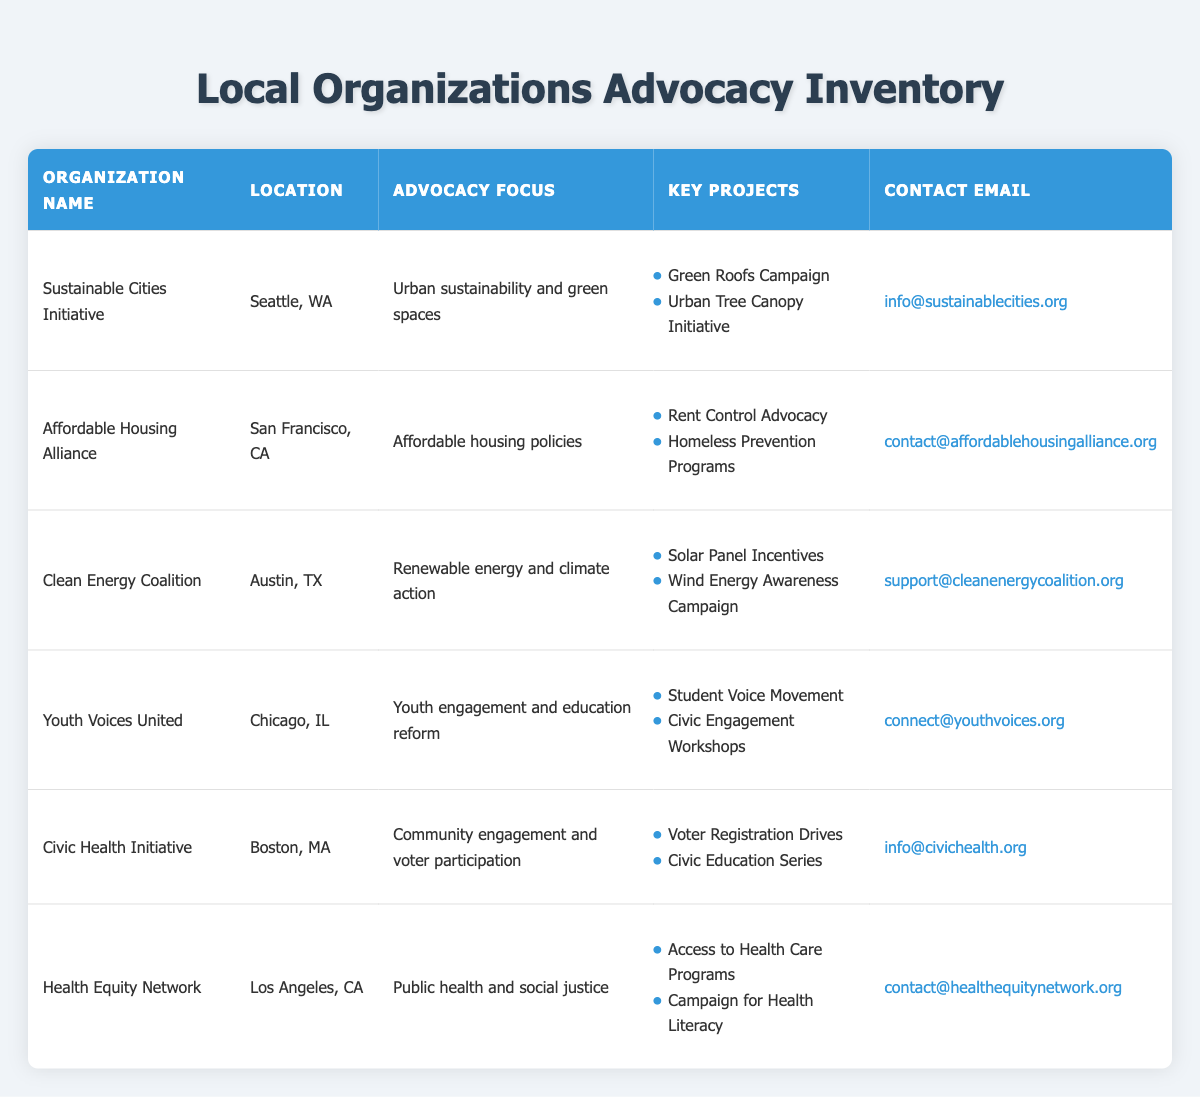What is the advocacy focus of the Clean Energy Coalition? The table shows that the advocacy focus of the Clean Energy Coalition, located in Austin, TX, is renewable energy and climate action.
Answer: Renewable energy and climate action Which organization is based in Boston, MA? Looking at the location column, the organization Civic Health Initiative is listed as being based in Boston, MA.
Answer: Civic Health Initiative Are any organizations focused on public health and social justice? The table indicates that Health Equity Network specifically focuses on public health and social justice, as stated in the advocacy focus column.
Answer: Yes How many organizations focus on youth engagement? In the table, there is only one organization that explicitly states its focus on youth engagement, which is Youth Voices United.
Answer: 1 What key project does the Affordable Housing Alliance have related to preventing homelessness? The table lists that among its key projects, the Affordable Housing Alliance has a "Homeless Prevention Programs" project aimed at this issue.
Answer: Homeless Prevention Programs Which organization has more than one key project listed? Upon reviewing the key projects for the listed organizations, all organizations have at least two key projects. Therefore, any organization can be considered, for example, the Sustainable Cities Initiative has two projects.
Answer: All organizations have more than one project What are the two key projects of the Youth Voices United? According to the key projects listed for Youth Voices United, they are "Student Voice Movement" and "Civic Engagement Workshops."
Answer: Student Voice Movement, Civic Engagement Workshops Is there any organization whose advocacy focus is on affordable housing policies? The Affordable Housing Alliance is specifically mentioned with the advocacy focus on affordable housing policies, making this statement true.
Answer: Yes What is the contact email for the Civic Health Initiative? The table shows that the contact email provided for the Civic Health Initiative is info@civichealth.org.
Answer: info@civichealth.org 